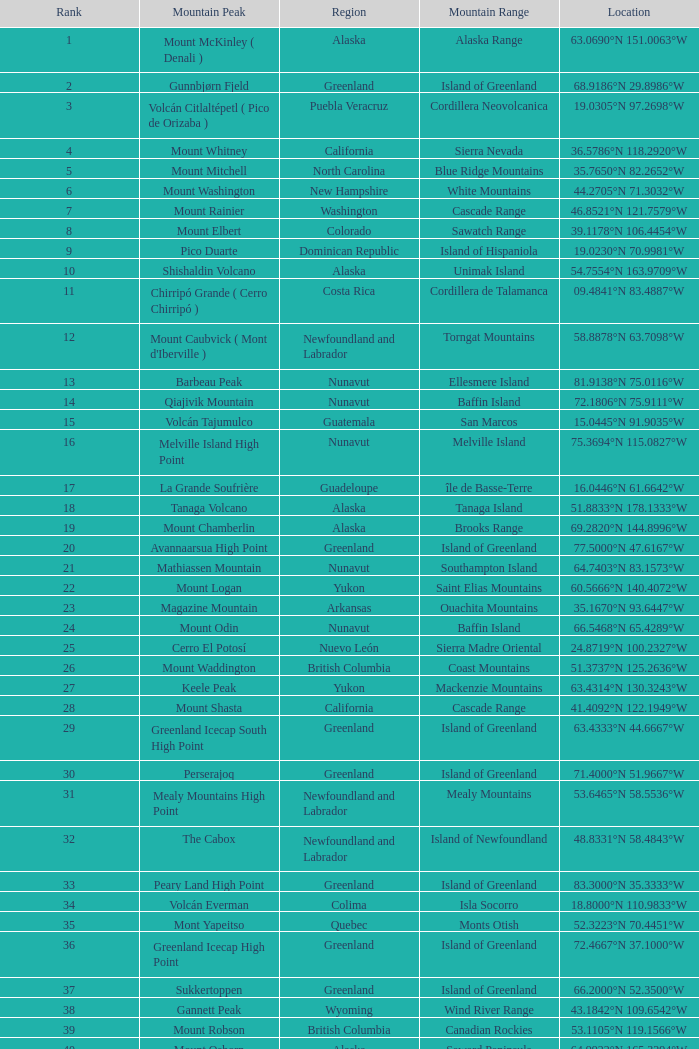Which mountain range encompasses a part of haiti situated at 18.3601°n 71.9764°w? Island of Hispaniola. 